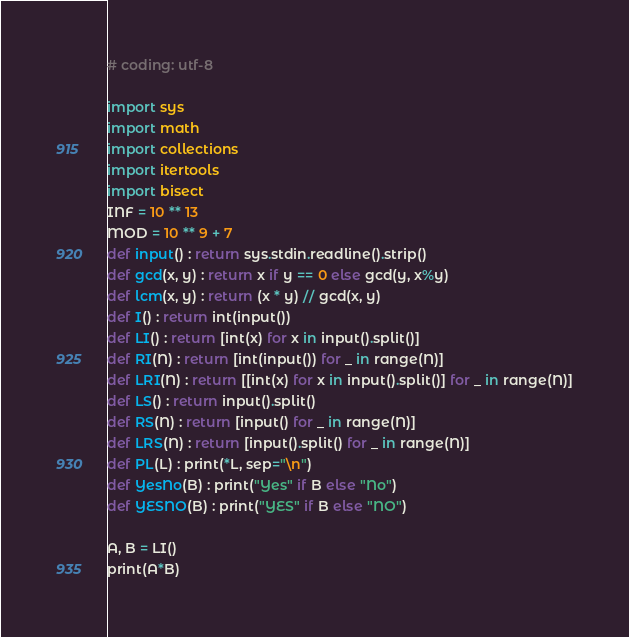Convert code to text. <code><loc_0><loc_0><loc_500><loc_500><_Python_># coding: utf-8

import sys
import math
import collections
import itertools
import bisect
INF = 10 ** 13
MOD = 10 ** 9 + 7
def input() : return sys.stdin.readline().strip()
def gcd(x, y) : return x if y == 0 else gcd(y, x%y)
def lcm(x, y) : return (x * y) // gcd(x, y)
def I() : return int(input())
def LI() : return [int(x) for x in input().split()]
def RI(N) : return [int(input()) for _ in range(N)]
def LRI(N) : return [[int(x) for x in input().split()] for _ in range(N)]
def LS() : return input().split()
def RS(N) : return [input() for _ in range(N)]
def LRS(N) : return [input().split() for _ in range(N)]
def PL(L) : print(*L, sep="\n")
def YesNo(B) : print("Yes" if B else "No")
def YESNO(B) : print("YES" if B else "NO")

A, B = LI()
print(A*B)
</code> 